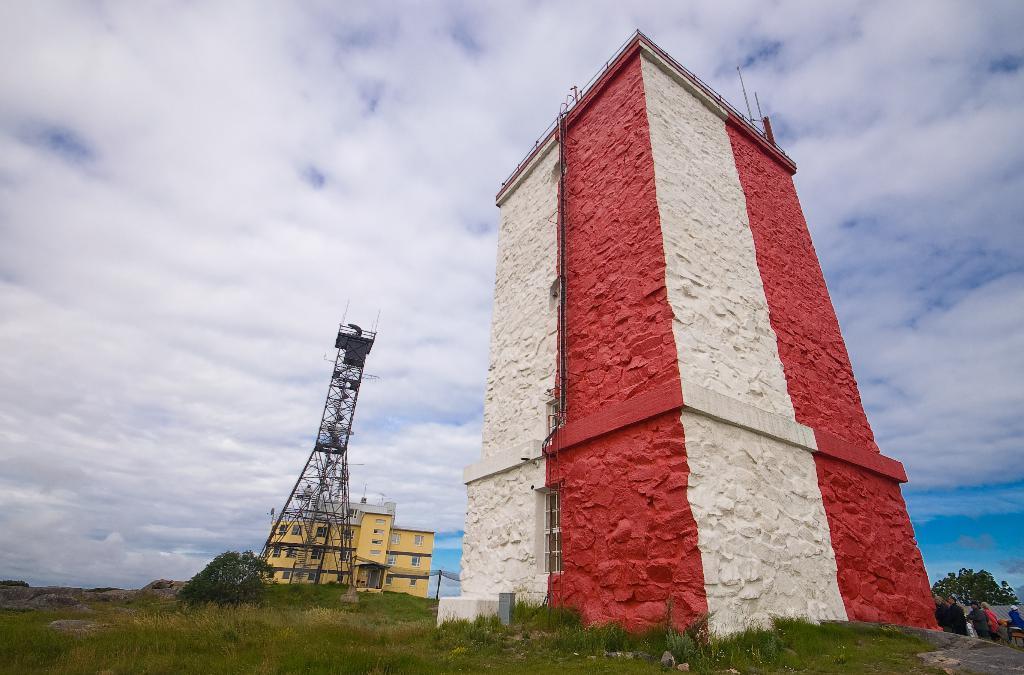Describe this image in one or two sentences. In this image there is tower in the middle. Behind the tower there is a building. At the bottom there is grass. At the top there is the sky. On the right side it looks like a building. 